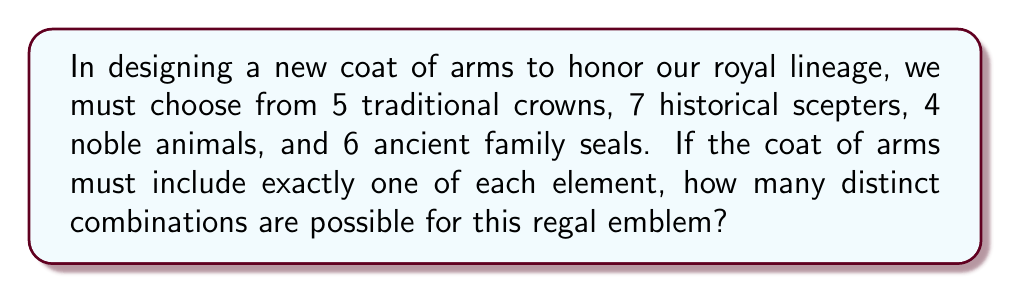Give your solution to this math problem. Let's approach this step-by-step using the Multiplication Principle of Counting:

1) We need to select one item from each category:
   - 1 crown from 5 options
   - 1 scepter from 7 options
   - 1 noble animal from 4 options
   - 1 family seal from 6 options

2) For each category, we have independent choices. This means we can multiply the number of options for each category:

   $$ \text{Total combinations} = 5 \times 7 \times 4 \times 6 $$

3) Let's calculate:
   $$ 5 \times 7 = 35 $$
   $$ 35 \times 4 = 140 $$
   $$ 140 \times 6 = 840 $$

Therefore, there are 840 distinct combinations possible for the new coat of arms.

This large number of possibilities allows for a unique emblem that both honors our rich history and distinguishes our royal house in the modern era.
Answer: 840 